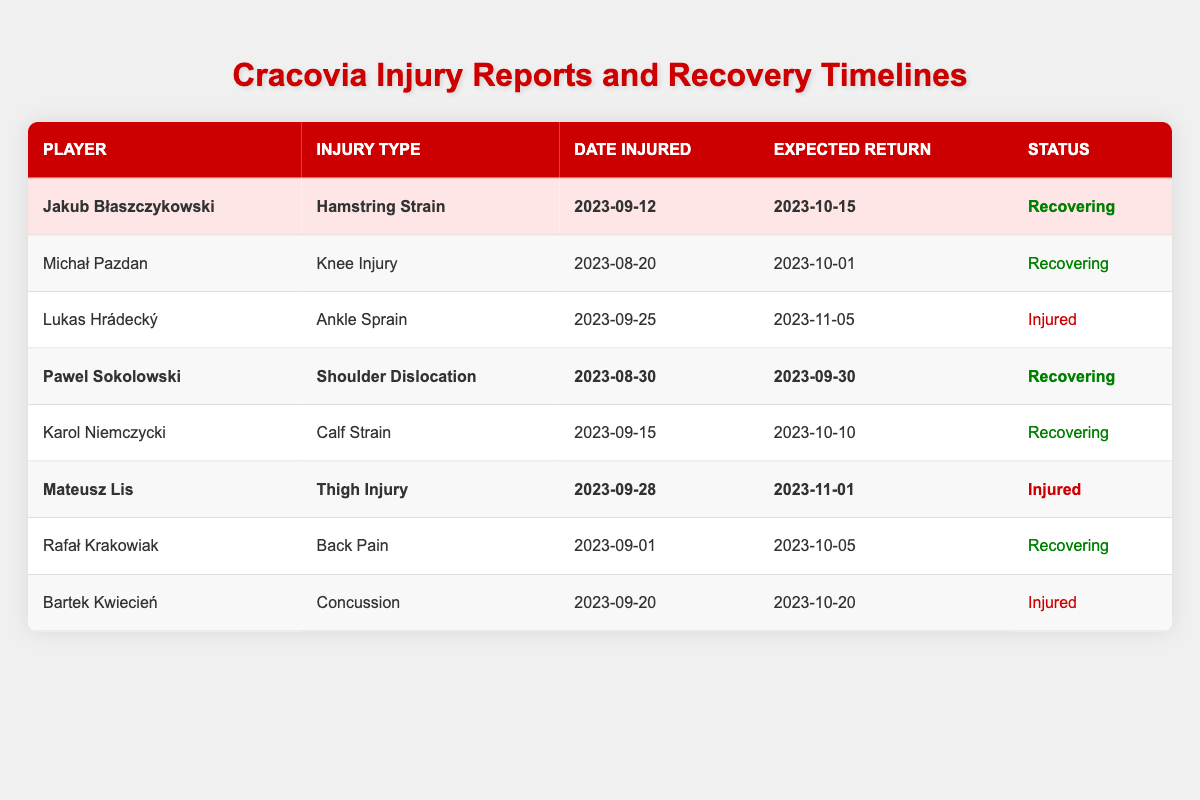What is the expected return date for Jakub Błaszczykowski? The table lists Jakub Błaszczykowski's expected return date as "2023-10-15." This info is directly presented in the "Expected Return" column for him.
Answer: 2023-10-15 How many players are currently recovering from injuries? The table shows three players with a "Recovering" status. I counted Jakub Błaszczykowski, Pawel Sokolowski, and Michał Pazdan under the "Status" column marked as "Recovering."
Answer: 4 What type of injury does Mateusz Lis have? The table states that Mateusz Lis has a "Thigh Injury." This information is directly available in the "Injury Type" column corresponding to his name.
Answer: Thigh Injury Which player is expected to return soonest? Comparing the expected return dates, Michał Pazdan has the earliest return date of "2023-10-01." I checked each player's expected return date to find the earliest.
Answer: Michał Pazdan Is there a player who has already returned from injury? No, all players listed either have a status of "Recovering" or "Injured," indicating none has returned yet. I reviewed the "Status" column for confirmations.
Answer: No How long will Jakub Błaszczykowski be out due to injury? To find out how long he will be out, I calculated the duration from the injury date (2023-09-12) to his expected return date (2023-10-15). That results in 33 days.
Answer: 33 days Are there any players expected to return in October? Yes, two players (Michał Pazdan on 2023-10-01 and Jakub Błaszczykowski on 2023-10-15) are expected to return in October. I looked at the expected return dates in the table.
Answer: Yes What is the total number of injuries reported for players highlighted in the table? There are three highlighted players: Jakub Błaszczykowski, Pawel Sokolowski, and Mateusz Lis, thus indicating three injuries reported. I counted the highlighted rows in the "Status" column.
Answer: 3 Which player has the condition with the longest recovery time expected? Lukas Hrádecký has the longest expected recovery period, returning on "2023-11-05," which I determined by comparing the expected return dates.
Answer: Lukas Hrádecký Who has a concussion injury? Bartek Kwiecień is the player with a "Concussion" injury type, as stated in the "Injury Type" column under his name.
Answer: Bartek Kwiecień What is the injury status of Pawel Sokolowski? Pawel Sokolowski is currently "Recovering" from a "Shoulder Dislocation," as stated in the "Status" column next to his name.
Answer: Recovering 